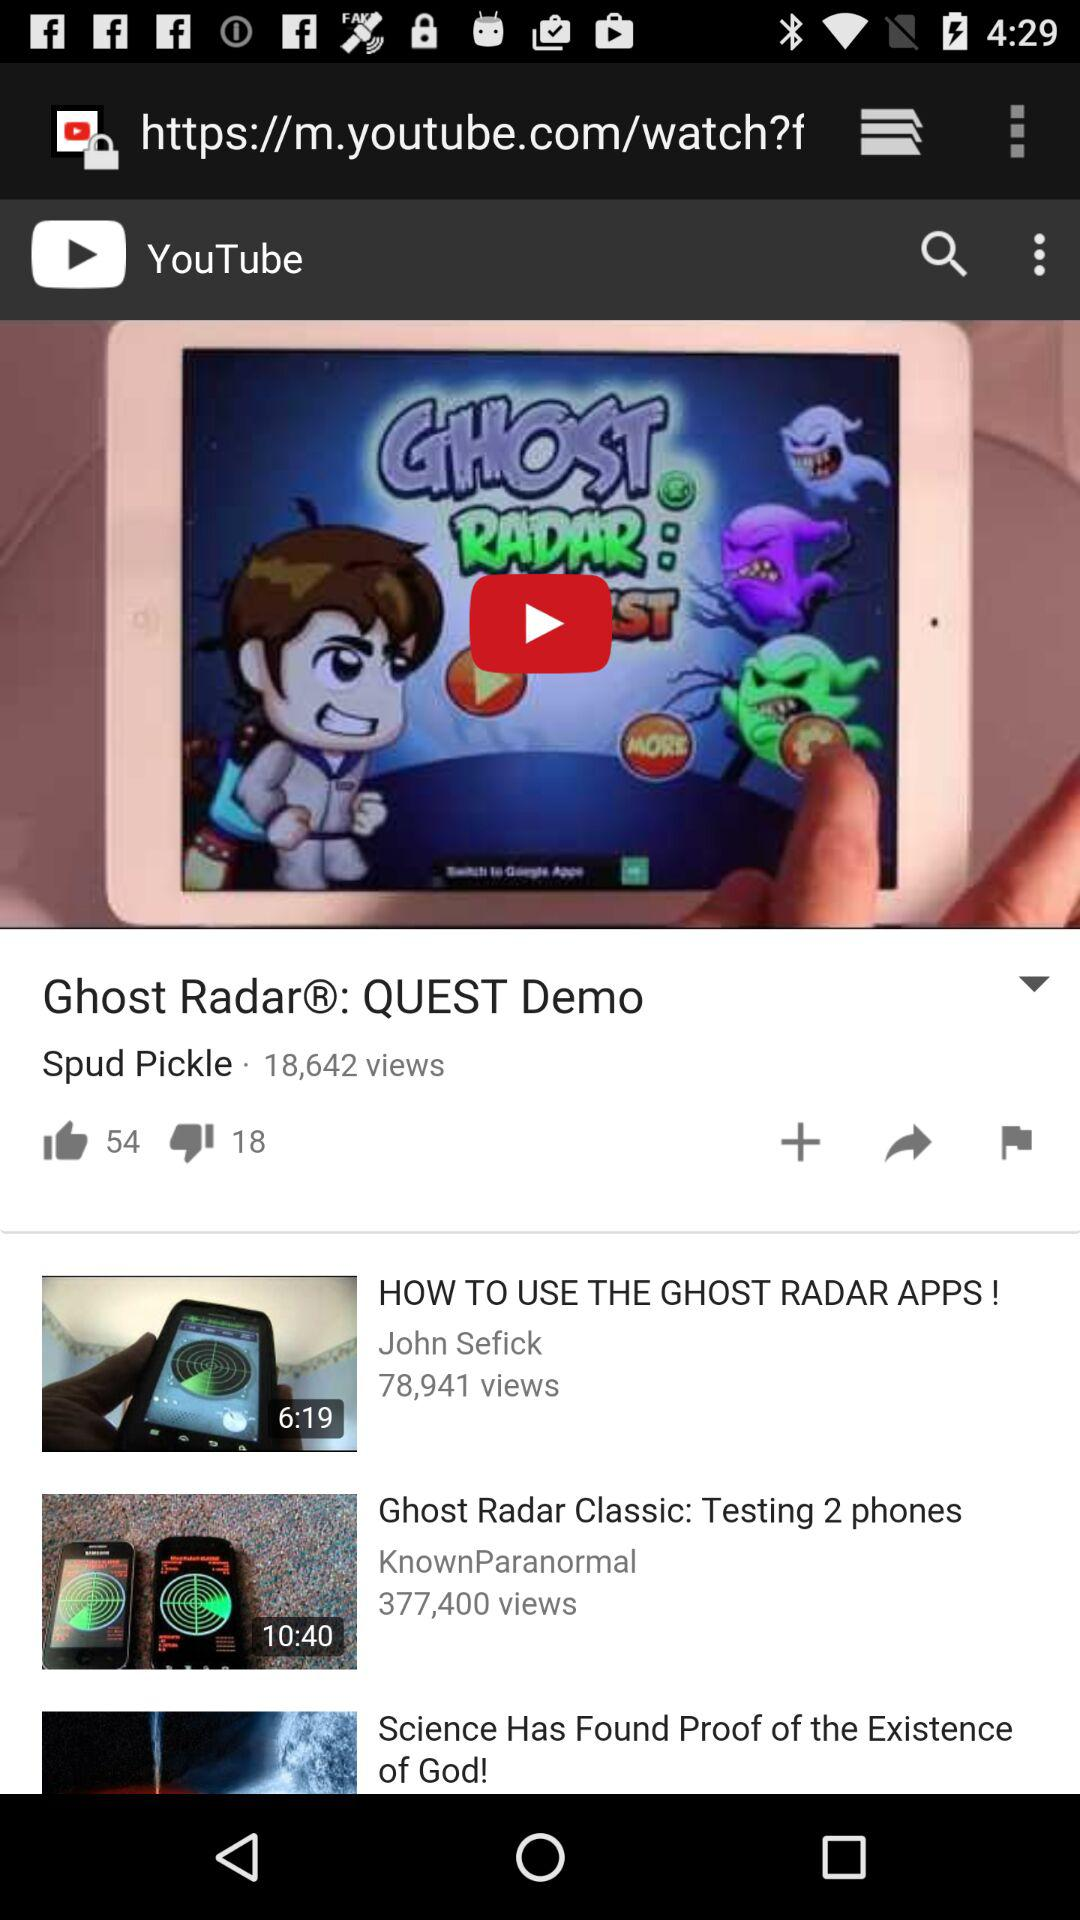How many people have watched the Ghost Radar Classic video? There are 377,400 people who watched the Ghost Radar Classic video. 